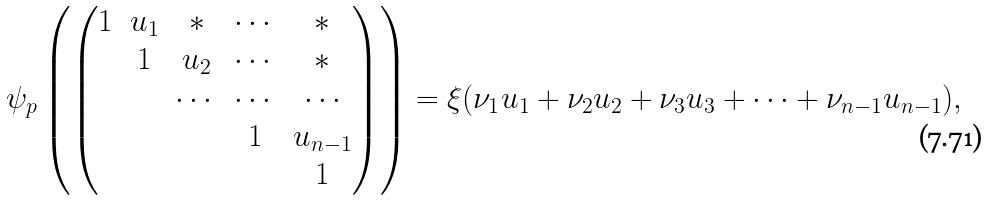<formula> <loc_0><loc_0><loc_500><loc_500>\psi _ { p } \left ( \begin{pmatrix} 1 & u _ { 1 } & * & \cdots & * \\ & 1 & u _ { 2 } & \cdots & * \\ & & \cdots & \cdots & \cdots \\ & & & 1 & u _ { n - 1 } \\ & & & & 1 \end{pmatrix} \right ) = \xi ( \nu _ { 1 } u _ { 1 } + \nu _ { 2 } u _ { 2 } + \nu _ { 3 } u _ { 3 } + \cdots + \nu _ { n - 1 } u _ { n - 1 } ) ,</formula> 